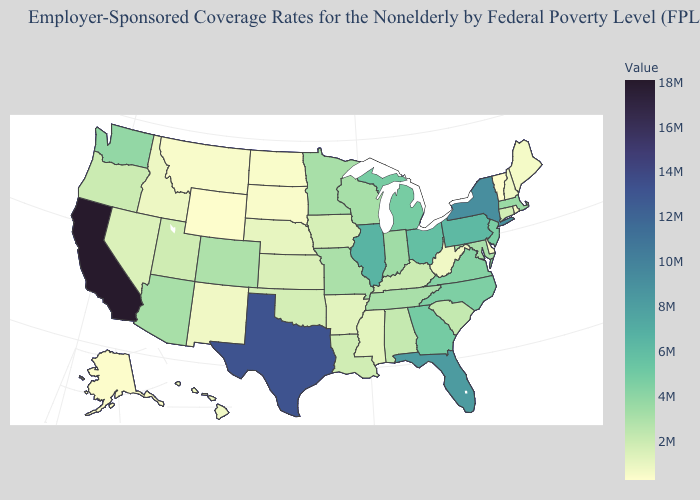Does Delaware have the lowest value in the South?
Quick response, please. Yes. Does Iowa have a lower value than Florida?
Quick response, please. Yes. Does Washington have the lowest value in the USA?
Concise answer only. No. Does Arizona have a higher value than New York?
Write a very short answer. No. Which states hav the highest value in the West?
Short answer required. California. 